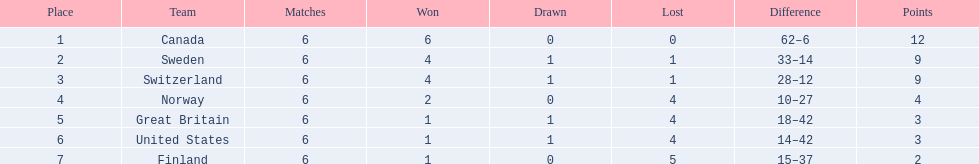What is the total number of teams to have 4 total wins? 2. 